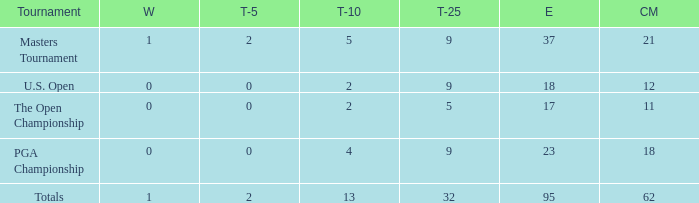What is the number of wins that is in the top 10 and larger than 13? None. 